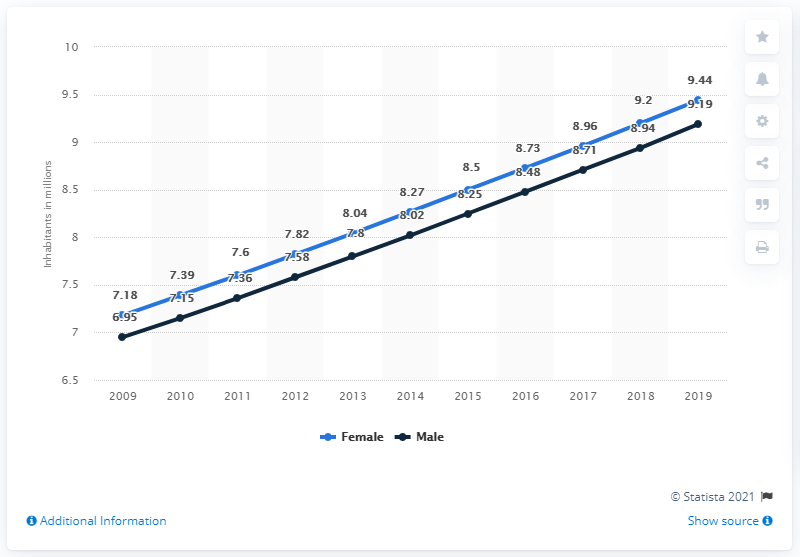Specify some key components in this picture. In 2019, the female population of Malawi was 9.44 million. In 2019, the male population of Malawi was 9.19 million. 